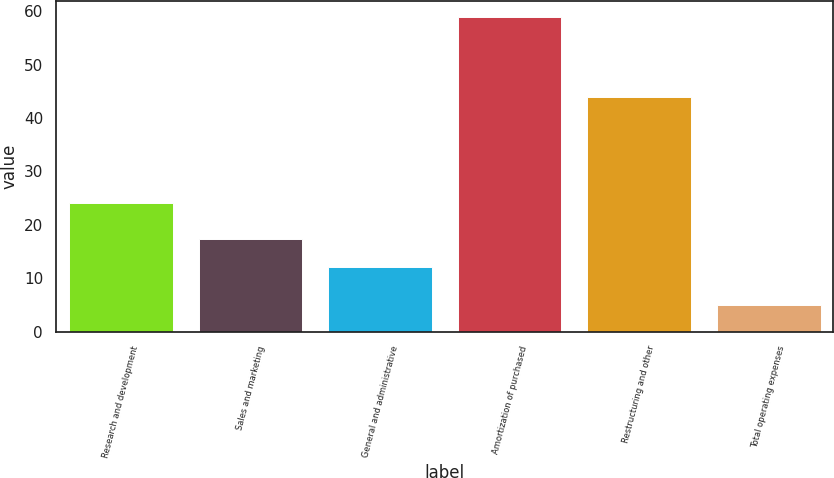Convert chart to OTSL. <chart><loc_0><loc_0><loc_500><loc_500><bar_chart><fcel>Research and development<fcel>Sales and marketing<fcel>General and administrative<fcel>Amortization of purchased<fcel>Restructuring and other<fcel>Total operating expenses<nl><fcel>24<fcel>17.4<fcel>12<fcel>59<fcel>44<fcel>5<nl></chart> 